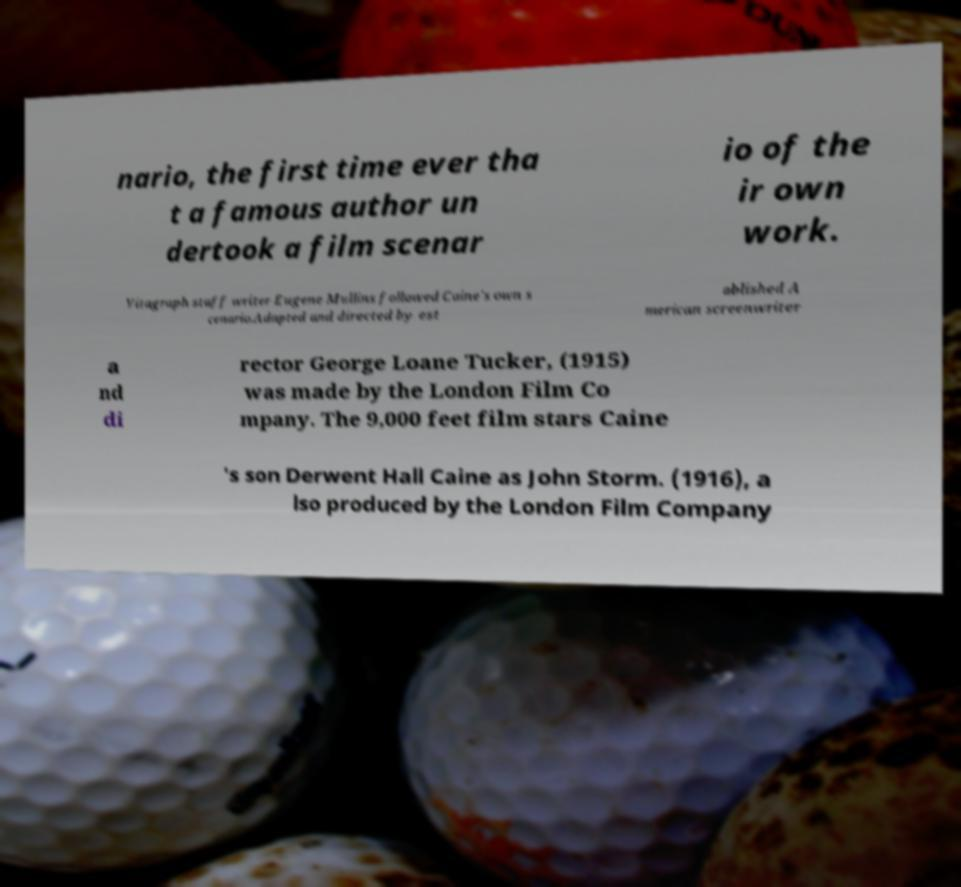Can you accurately transcribe the text from the provided image for me? nario, the first time ever tha t a famous author un dertook a film scenar io of the ir own work. Vitagraph staff writer Eugene Mullins followed Caine's own s cenario.Adapted and directed by est ablished A merican screenwriter a nd di rector George Loane Tucker, (1915) was made by the London Film Co mpany. The 9,000 feet film stars Caine 's son Derwent Hall Caine as John Storm. (1916), a lso produced by the London Film Company 